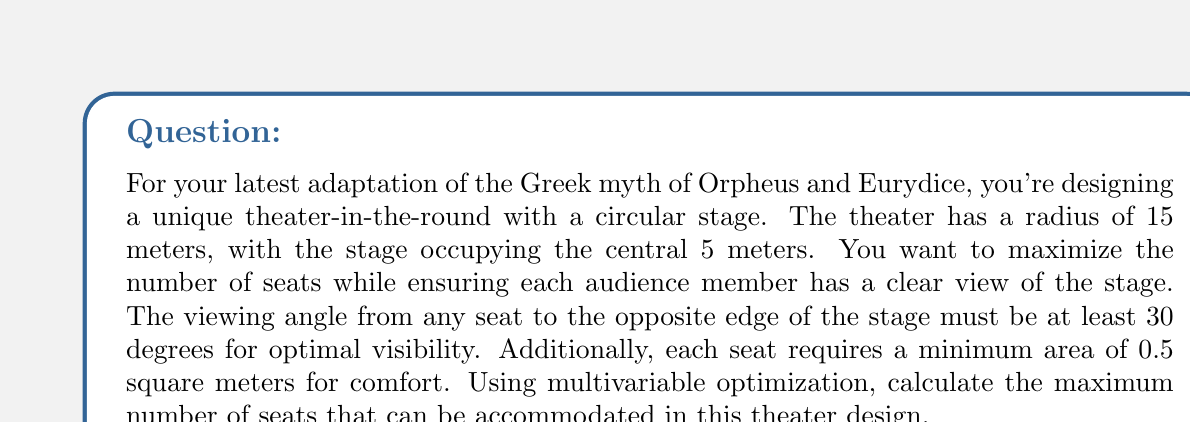Can you answer this question? Let's approach this problem step-by-step using multivariable optimization:

1) First, we need to define our variables:
   Let $r$ be the distance from the center of the theater to the first row of seats.
   Let $w$ be the width of the seating area.

2) The constraints of our problem are:
   a) $5 \leq r \leq 15$ (the seating starts after the stage and ends at the theater's edge)
   b) $0 \leq w \leq 15 - r$ (the seating width can't exceed the remaining radius)
   c) $\tan^{-1}(\frac{5}{r+w}) \geq 30°$ (viewing angle constraint)

3) The area of the seating section is given by:
   $A = \pi((r+w)^2 - r^2) = \pi(2rw + w^2)$

4) The number of seats is this area divided by the area per seat:
   $N = \frac{\pi(2rw + w^2)}{0.5} = 2\pi(2rw + w^2)$

5) Our objective is to maximize $N$ subject to the constraints.

6) The viewing angle constraint can be rewritten as:
   $w \leq r\tan(30°) - 5 \approx 0.577r - 5$

7) Using the method of Lagrange multipliers, we can solve this optimization problem. The solution occurs when:
   $\frac{\partial N}{\partial r} = \frac{\partial N}{\partial w} = 0$

8) Solving these equations simultaneously with the constraints leads to:
   $r \approx 8.66$ meters
   $w \approx 6.34$ meters

9) Substituting these values back into our equation for $N$:
   $N = 2\pi(2 \cdot 8.66 \cdot 6.34 + 6.34^2) \approx 730.6$

10) Since we can only have a whole number of seats, we round down to 730.
Answer: The maximum number of seats that can be accommodated in this theater design is 730. 